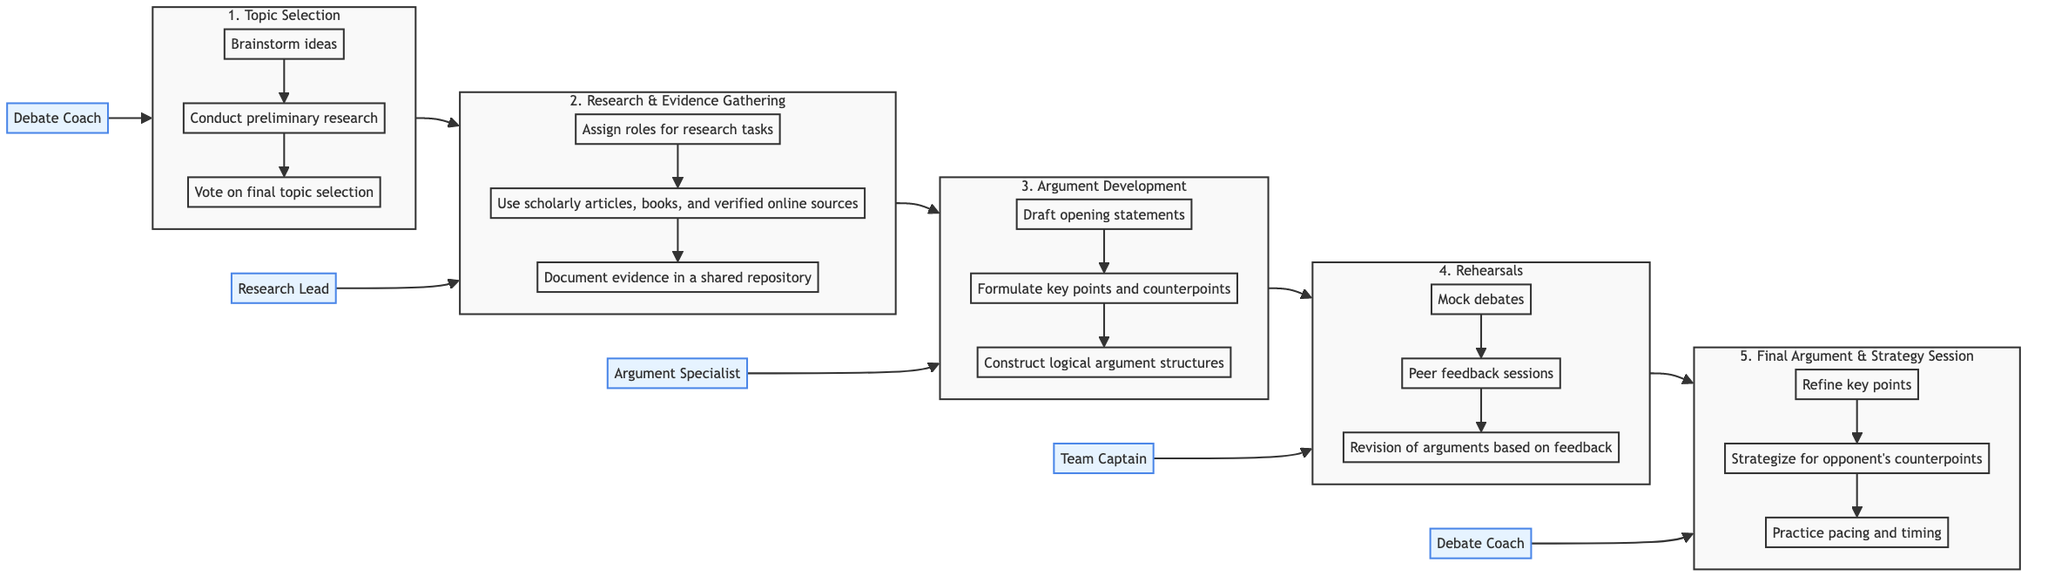What is the first step in the debate preparation process? The first step in the diagram is labeled "1. Topic Selection." It is positioned at the very beginning of the flowchart indicating the starting point of the process.
Answer: Topic Selection Who is responsible for the "Research & Evidence Gathering" step? The diagram indicates that the "Research Lead" is the person in charge of this step. This is shown in the flowchart node connected specifically to the second step.
Answer: Research Lead How many main steps are there in the process? By counting the major steps in the flowchart, we find there are five distinct steps outlined from Topic Selection to Final Argument & Strategy Session.
Answer: 5 What activities follow "Conduct preliminary research"? The flowchart indicates that the next activity after "Conduct preliminary research" is "Vote on final topic selection" which is part of the first step, Topic Selection.
Answer: Vote on final topic selection What is the last activity in the "Rehearsals" step? The final activity listed in the "Rehearsals" step is "Revision of arguments based on feedback." This comes after the mock debates and peer feedback sessions in the fourth step.
Answer: Revision of arguments based on feedback Which step involves the "Team Captain"? The "Team Captain" is responsible for the "Rehearsals" step, which is the fourth part of the process as indicated in the diagram.
Answer: Rehearsals What is the sequence of steps from the beginning to the final session? The diagram outlines a sequence from "Topic Selection" to "Research & Evidence Gathering," then to "Argument Development," followed by "Rehearsals," and finally "Final Argument & Strategy Session." This linear flow defines the order of the steps in the preparation process.
Answer: Topic Selection, Research & Evidence Gathering, Argument Development, Rehearsals, Final Argument & Strategy Session How does "Argument Development" relate to "Final Argument & Strategy Session"? "Argument Development" is the third step in the flowchart that directly precedes the "Final Argument & Strategy Session," indicating that the arguments developed influence the strategy and final preparations for the debate.
Answer: Directly precedes What activity is associated with the "Debate Coach" in the final step? In the "Final Argument & Strategy Session" step, the activity associated with the "Debate Coach" is "Practice pacing and timing," as this is one of the three activities listed under this final step.
Answer: Practice pacing and timing 